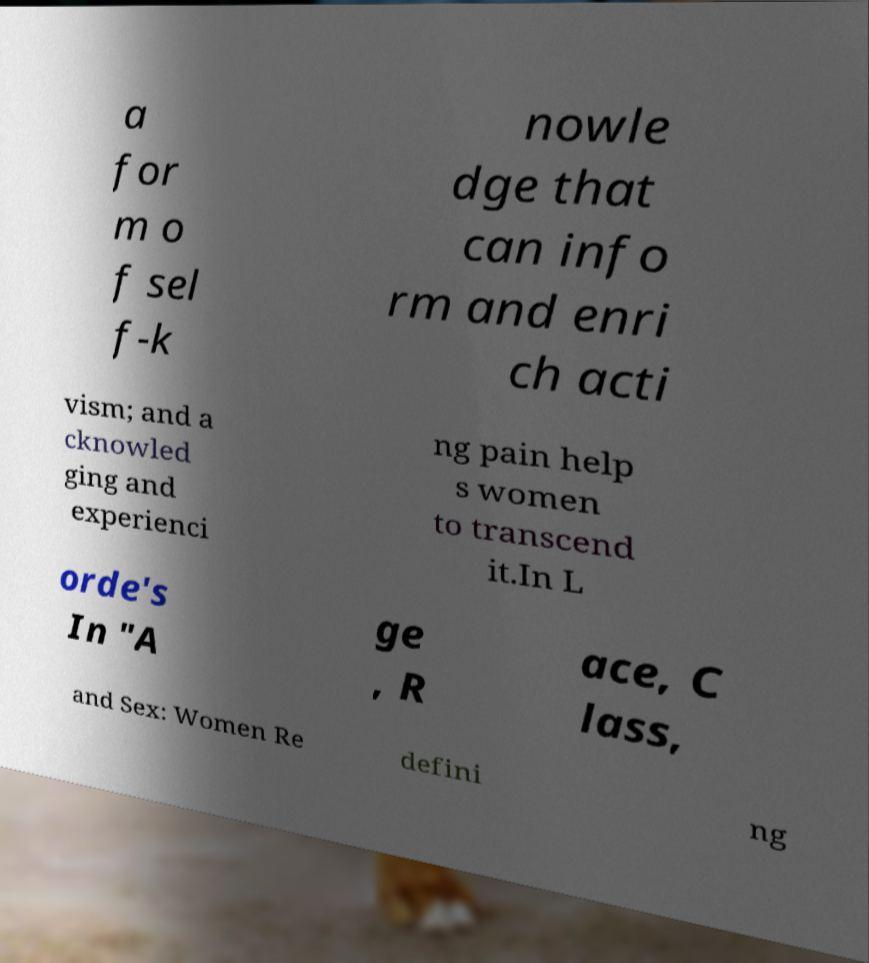Can you read and provide the text displayed in the image?This photo seems to have some interesting text. Can you extract and type it out for me? a for m o f sel f-k nowle dge that can info rm and enri ch acti vism; and a cknowled ging and experienci ng pain help s women to transcend it.In L orde's In "A ge , R ace, C lass, and Sex: Women Re defini ng 